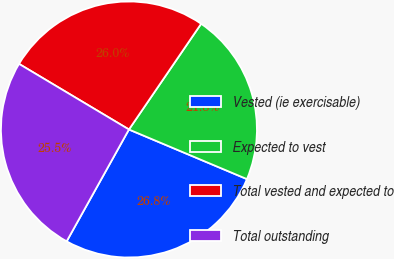<chart> <loc_0><loc_0><loc_500><loc_500><pie_chart><fcel>Vested (ie exercisable)<fcel>Expected to vest<fcel>Total vested and expected to<fcel>Total outstanding<nl><fcel>26.75%<fcel>21.8%<fcel>25.97%<fcel>25.48%<nl></chart> 